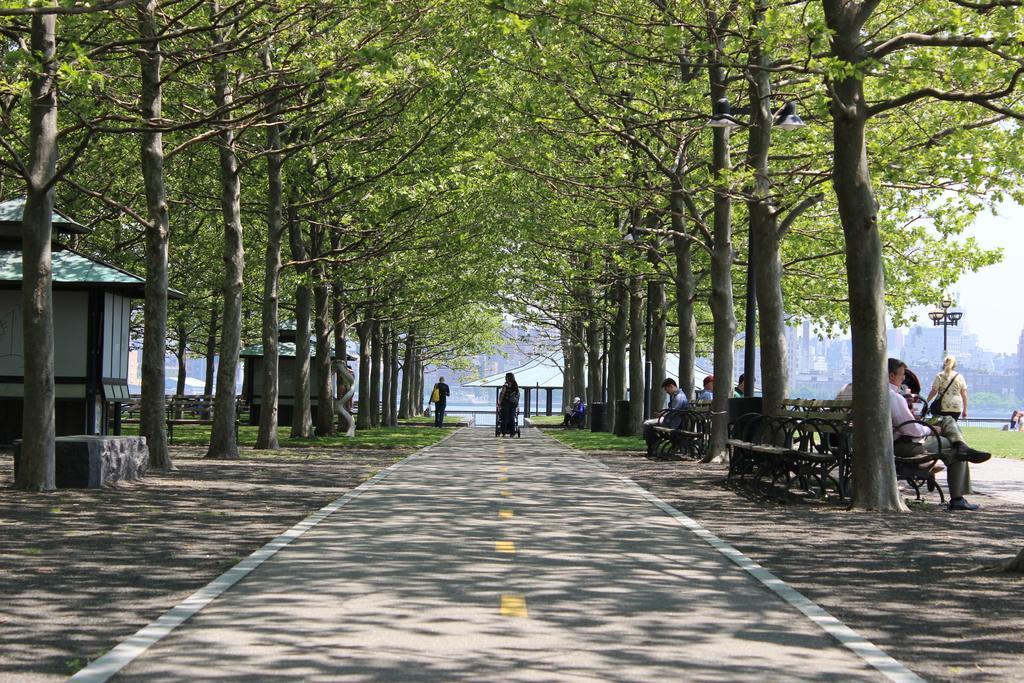Can you describe this image briefly? In this image we can see the houses, buildings, light pole, benches, grass and also the trees. We can also see the road, people, path and also the sky. In the background we can see the roof for shelter. 